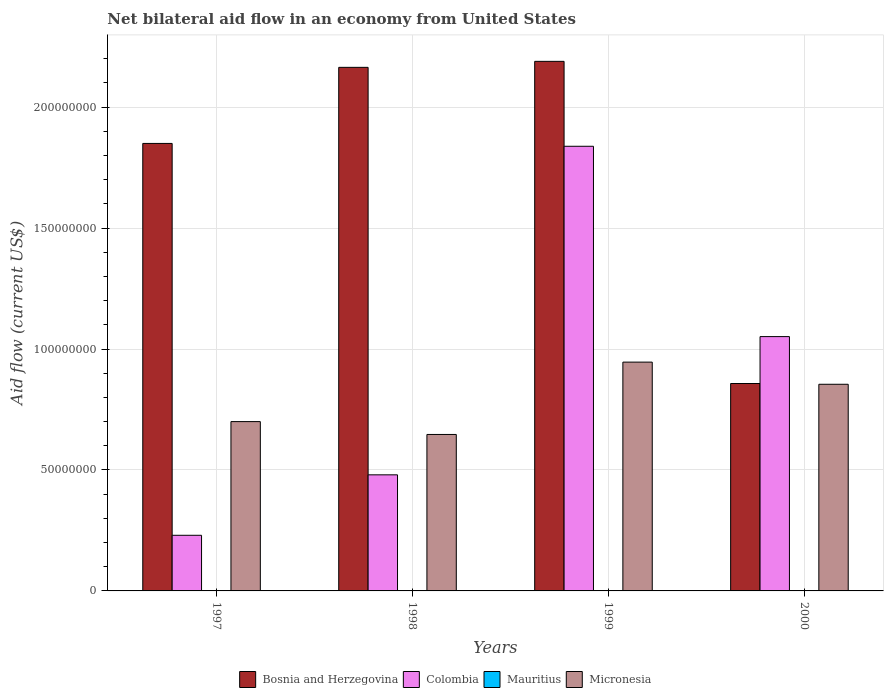Are the number of bars per tick equal to the number of legend labels?
Provide a succinct answer. No. How many bars are there on the 1st tick from the left?
Your response must be concise. 3. How many bars are there on the 4th tick from the right?
Ensure brevity in your answer.  3. What is the net bilateral aid flow in Colombia in 1997?
Ensure brevity in your answer.  2.30e+07. Across all years, what is the maximum net bilateral aid flow in Colombia?
Give a very brief answer. 1.84e+08. In which year was the net bilateral aid flow in Bosnia and Herzegovina maximum?
Provide a succinct answer. 1999. What is the total net bilateral aid flow in Colombia in the graph?
Make the answer very short. 3.60e+08. What is the difference between the net bilateral aid flow in Bosnia and Herzegovina in 1998 and that in 2000?
Offer a very short reply. 1.31e+08. What is the difference between the net bilateral aid flow in Bosnia and Herzegovina in 1997 and the net bilateral aid flow in Mauritius in 1999?
Give a very brief answer. 1.85e+08. What is the average net bilateral aid flow in Colombia per year?
Offer a very short reply. 9.00e+07. In the year 2000, what is the difference between the net bilateral aid flow in Colombia and net bilateral aid flow in Bosnia and Herzegovina?
Give a very brief answer. 1.94e+07. What is the ratio of the net bilateral aid flow in Micronesia in 1998 to that in 2000?
Give a very brief answer. 0.76. Is the difference between the net bilateral aid flow in Colombia in 1997 and 2000 greater than the difference between the net bilateral aid flow in Bosnia and Herzegovina in 1997 and 2000?
Offer a terse response. No. What is the difference between the highest and the second highest net bilateral aid flow in Micronesia?
Offer a terse response. 9.16e+06. What is the difference between the highest and the lowest net bilateral aid flow in Bosnia and Herzegovina?
Provide a short and direct response. 1.33e+08. In how many years, is the net bilateral aid flow in Mauritius greater than the average net bilateral aid flow in Mauritius taken over all years?
Provide a succinct answer. 0. Is the sum of the net bilateral aid flow in Colombia in 1998 and 2000 greater than the maximum net bilateral aid flow in Bosnia and Herzegovina across all years?
Offer a terse response. No. Is it the case that in every year, the sum of the net bilateral aid flow in Bosnia and Herzegovina and net bilateral aid flow in Mauritius is greater than the sum of net bilateral aid flow in Colombia and net bilateral aid flow in Micronesia?
Offer a very short reply. No. Is it the case that in every year, the sum of the net bilateral aid flow in Colombia and net bilateral aid flow in Micronesia is greater than the net bilateral aid flow in Mauritius?
Your answer should be compact. Yes. Are all the bars in the graph horizontal?
Offer a terse response. No. Does the graph contain any zero values?
Give a very brief answer. Yes. Does the graph contain grids?
Ensure brevity in your answer.  Yes. Where does the legend appear in the graph?
Give a very brief answer. Bottom center. How many legend labels are there?
Your answer should be compact. 4. How are the legend labels stacked?
Provide a short and direct response. Horizontal. What is the title of the graph?
Provide a succinct answer. Net bilateral aid flow in an economy from United States. What is the label or title of the X-axis?
Make the answer very short. Years. What is the label or title of the Y-axis?
Ensure brevity in your answer.  Aid flow (current US$). What is the Aid flow (current US$) of Bosnia and Herzegovina in 1997?
Offer a very short reply. 1.85e+08. What is the Aid flow (current US$) in Colombia in 1997?
Offer a very short reply. 2.30e+07. What is the Aid flow (current US$) in Micronesia in 1997?
Offer a terse response. 7.00e+07. What is the Aid flow (current US$) of Bosnia and Herzegovina in 1998?
Offer a terse response. 2.16e+08. What is the Aid flow (current US$) in Colombia in 1998?
Provide a short and direct response. 4.80e+07. What is the Aid flow (current US$) of Mauritius in 1998?
Provide a short and direct response. 0. What is the Aid flow (current US$) in Micronesia in 1998?
Offer a terse response. 6.47e+07. What is the Aid flow (current US$) of Bosnia and Herzegovina in 1999?
Provide a short and direct response. 2.19e+08. What is the Aid flow (current US$) of Colombia in 1999?
Your response must be concise. 1.84e+08. What is the Aid flow (current US$) in Micronesia in 1999?
Offer a terse response. 9.46e+07. What is the Aid flow (current US$) of Bosnia and Herzegovina in 2000?
Your response must be concise. 8.58e+07. What is the Aid flow (current US$) of Colombia in 2000?
Ensure brevity in your answer.  1.05e+08. What is the Aid flow (current US$) of Micronesia in 2000?
Provide a succinct answer. 8.54e+07. Across all years, what is the maximum Aid flow (current US$) of Bosnia and Herzegovina?
Offer a terse response. 2.19e+08. Across all years, what is the maximum Aid flow (current US$) in Colombia?
Offer a very short reply. 1.84e+08. Across all years, what is the maximum Aid flow (current US$) of Micronesia?
Your answer should be very brief. 9.46e+07. Across all years, what is the minimum Aid flow (current US$) of Bosnia and Herzegovina?
Make the answer very short. 8.58e+07. Across all years, what is the minimum Aid flow (current US$) in Colombia?
Make the answer very short. 2.30e+07. Across all years, what is the minimum Aid flow (current US$) in Micronesia?
Your response must be concise. 6.47e+07. What is the total Aid flow (current US$) of Bosnia and Herzegovina in the graph?
Offer a terse response. 7.06e+08. What is the total Aid flow (current US$) of Colombia in the graph?
Your answer should be compact. 3.60e+08. What is the total Aid flow (current US$) of Micronesia in the graph?
Provide a short and direct response. 3.15e+08. What is the difference between the Aid flow (current US$) of Bosnia and Herzegovina in 1997 and that in 1998?
Provide a short and direct response. -3.14e+07. What is the difference between the Aid flow (current US$) in Colombia in 1997 and that in 1998?
Provide a short and direct response. -2.50e+07. What is the difference between the Aid flow (current US$) in Micronesia in 1997 and that in 1998?
Offer a very short reply. 5.32e+06. What is the difference between the Aid flow (current US$) of Bosnia and Herzegovina in 1997 and that in 1999?
Provide a short and direct response. -3.39e+07. What is the difference between the Aid flow (current US$) in Colombia in 1997 and that in 1999?
Keep it short and to the point. -1.61e+08. What is the difference between the Aid flow (current US$) of Micronesia in 1997 and that in 1999?
Ensure brevity in your answer.  -2.46e+07. What is the difference between the Aid flow (current US$) in Bosnia and Herzegovina in 1997 and that in 2000?
Provide a short and direct response. 9.92e+07. What is the difference between the Aid flow (current US$) of Colombia in 1997 and that in 2000?
Give a very brief answer. -8.21e+07. What is the difference between the Aid flow (current US$) in Micronesia in 1997 and that in 2000?
Provide a short and direct response. -1.54e+07. What is the difference between the Aid flow (current US$) in Bosnia and Herzegovina in 1998 and that in 1999?
Provide a succinct answer. -2.48e+06. What is the difference between the Aid flow (current US$) of Colombia in 1998 and that in 1999?
Provide a succinct answer. -1.36e+08. What is the difference between the Aid flow (current US$) in Micronesia in 1998 and that in 1999?
Your answer should be very brief. -2.99e+07. What is the difference between the Aid flow (current US$) of Bosnia and Herzegovina in 1998 and that in 2000?
Offer a terse response. 1.31e+08. What is the difference between the Aid flow (current US$) of Colombia in 1998 and that in 2000?
Offer a terse response. -5.72e+07. What is the difference between the Aid flow (current US$) of Micronesia in 1998 and that in 2000?
Your response must be concise. -2.08e+07. What is the difference between the Aid flow (current US$) of Bosnia and Herzegovina in 1999 and that in 2000?
Keep it short and to the point. 1.33e+08. What is the difference between the Aid flow (current US$) in Colombia in 1999 and that in 2000?
Offer a terse response. 7.87e+07. What is the difference between the Aid flow (current US$) of Micronesia in 1999 and that in 2000?
Provide a succinct answer. 9.16e+06. What is the difference between the Aid flow (current US$) in Bosnia and Herzegovina in 1997 and the Aid flow (current US$) in Colombia in 1998?
Offer a very short reply. 1.37e+08. What is the difference between the Aid flow (current US$) of Bosnia and Herzegovina in 1997 and the Aid flow (current US$) of Micronesia in 1998?
Ensure brevity in your answer.  1.20e+08. What is the difference between the Aid flow (current US$) of Colombia in 1997 and the Aid flow (current US$) of Micronesia in 1998?
Offer a very short reply. -4.17e+07. What is the difference between the Aid flow (current US$) in Bosnia and Herzegovina in 1997 and the Aid flow (current US$) in Colombia in 1999?
Make the answer very short. 1.18e+06. What is the difference between the Aid flow (current US$) in Bosnia and Herzegovina in 1997 and the Aid flow (current US$) in Micronesia in 1999?
Your answer should be compact. 9.04e+07. What is the difference between the Aid flow (current US$) of Colombia in 1997 and the Aid flow (current US$) of Micronesia in 1999?
Make the answer very short. -7.16e+07. What is the difference between the Aid flow (current US$) in Bosnia and Herzegovina in 1997 and the Aid flow (current US$) in Colombia in 2000?
Offer a very short reply. 7.99e+07. What is the difference between the Aid flow (current US$) in Bosnia and Herzegovina in 1997 and the Aid flow (current US$) in Micronesia in 2000?
Your response must be concise. 9.96e+07. What is the difference between the Aid flow (current US$) of Colombia in 1997 and the Aid flow (current US$) of Micronesia in 2000?
Keep it short and to the point. -6.24e+07. What is the difference between the Aid flow (current US$) of Bosnia and Herzegovina in 1998 and the Aid flow (current US$) of Colombia in 1999?
Your answer should be compact. 3.26e+07. What is the difference between the Aid flow (current US$) in Bosnia and Herzegovina in 1998 and the Aid flow (current US$) in Micronesia in 1999?
Provide a succinct answer. 1.22e+08. What is the difference between the Aid flow (current US$) in Colombia in 1998 and the Aid flow (current US$) in Micronesia in 1999?
Offer a terse response. -4.66e+07. What is the difference between the Aid flow (current US$) of Bosnia and Herzegovina in 1998 and the Aid flow (current US$) of Colombia in 2000?
Keep it short and to the point. 1.11e+08. What is the difference between the Aid flow (current US$) of Bosnia and Herzegovina in 1998 and the Aid flow (current US$) of Micronesia in 2000?
Your answer should be very brief. 1.31e+08. What is the difference between the Aid flow (current US$) of Colombia in 1998 and the Aid flow (current US$) of Micronesia in 2000?
Make the answer very short. -3.74e+07. What is the difference between the Aid flow (current US$) in Bosnia and Herzegovina in 1999 and the Aid flow (current US$) in Colombia in 2000?
Your response must be concise. 1.14e+08. What is the difference between the Aid flow (current US$) of Bosnia and Herzegovina in 1999 and the Aid flow (current US$) of Micronesia in 2000?
Your answer should be compact. 1.34e+08. What is the difference between the Aid flow (current US$) of Colombia in 1999 and the Aid flow (current US$) of Micronesia in 2000?
Offer a terse response. 9.84e+07. What is the average Aid flow (current US$) in Bosnia and Herzegovina per year?
Provide a succinct answer. 1.77e+08. What is the average Aid flow (current US$) in Colombia per year?
Your response must be concise. 9.00e+07. What is the average Aid flow (current US$) in Mauritius per year?
Offer a very short reply. 0. What is the average Aid flow (current US$) of Micronesia per year?
Keep it short and to the point. 7.87e+07. In the year 1997, what is the difference between the Aid flow (current US$) of Bosnia and Herzegovina and Aid flow (current US$) of Colombia?
Offer a very short reply. 1.62e+08. In the year 1997, what is the difference between the Aid flow (current US$) in Bosnia and Herzegovina and Aid flow (current US$) in Micronesia?
Provide a short and direct response. 1.15e+08. In the year 1997, what is the difference between the Aid flow (current US$) in Colombia and Aid flow (current US$) in Micronesia?
Your answer should be compact. -4.70e+07. In the year 1998, what is the difference between the Aid flow (current US$) in Bosnia and Herzegovina and Aid flow (current US$) in Colombia?
Ensure brevity in your answer.  1.68e+08. In the year 1998, what is the difference between the Aid flow (current US$) of Bosnia and Herzegovina and Aid flow (current US$) of Micronesia?
Your response must be concise. 1.52e+08. In the year 1998, what is the difference between the Aid flow (current US$) in Colombia and Aid flow (current US$) in Micronesia?
Your answer should be very brief. -1.67e+07. In the year 1999, what is the difference between the Aid flow (current US$) of Bosnia and Herzegovina and Aid flow (current US$) of Colombia?
Keep it short and to the point. 3.51e+07. In the year 1999, what is the difference between the Aid flow (current US$) in Bosnia and Herzegovina and Aid flow (current US$) in Micronesia?
Your answer should be very brief. 1.24e+08. In the year 1999, what is the difference between the Aid flow (current US$) of Colombia and Aid flow (current US$) of Micronesia?
Keep it short and to the point. 8.92e+07. In the year 2000, what is the difference between the Aid flow (current US$) of Bosnia and Herzegovina and Aid flow (current US$) of Colombia?
Provide a succinct answer. -1.94e+07. In the year 2000, what is the difference between the Aid flow (current US$) of Bosnia and Herzegovina and Aid flow (current US$) of Micronesia?
Offer a very short reply. 3.20e+05. In the year 2000, what is the difference between the Aid flow (current US$) in Colombia and Aid flow (current US$) in Micronesia?
Your response must be concise. 1.97e+07. What is the ratio of the Aid flow (current US$) in Bosnia and Herzegovina in 1997 to that in 1998?
Provide a short and direct response. 0.85. What is the ratio of the Aid flow (current US$) in Colombia in 1997 to that in 1998?
Your answer should be compact. 0.48. What is the ratio of the Aid flow (current US$) of Micronesia in 1997 to that in 1998?
Keep it short and to the point. 1.08. What is the ratio of the Aid flow (current US$) of Bosnia and Herzegovina in 1997 to that in 1999?
Offer a very short reply. 0.84. What is the ratio of the Aid flow (current US$) of Colombia in 1997 to that in 1999?
Your answer should be compact. 0.13. What is the ratio of the Aid flow (current US$) of Micronesia in 1997 to that in 1999?
Give a very brief answer. 0.74. What is the ratio of the Aid flow (current US$) of Bosnia and Herzegovina in 1997 to that in 2000?
Provide a short and direct response. 2.16. What is the ratio of the Aid flow (current US$) in Colombia in 1997 to that in 2000?
Provide a succinct answer. 0.22. What is the ratio of the Aid flow (current US$) of Micronesia in 1997 to that in 2000?
Make the answer very short. 0.82. What is the ratio of the Aid flow (current US$) of Bosnia and Herzegovina in 1998 to that in 1999?
Offer a very short reply. 0.99. What is the ratio of the Aid flow (current US$) in Colombia in 1998 to that in 1999?
Your answer should be very brief. 0.26. What is the ratio of the Aid flow (current US$) of Micronesia in 1998 to that in 1999?
Provide a short and direct response. 0.68. What is the ratio of the Aid flow (current US$) of Bosnia and Herzegovina in 1998 to that in 2000?
Ensure brevity in your answer.  2.52. What is the ratio of the Aid flow (current US$) of Colombia in 1998 to that in 2000?
Your response must be concise. 0.46. What is the ratio of the Aid flow (current US$) in Micronesia in 1998 to that in 2000?
Your answer should be compact. 0.76. What is the ratio of the Aid flow (current US$) of Bosnia and Herzegovina in 1999 to that in 2000?
Offer a very short reply. 2.55. What is the ratio of the Aid flow (current US$) in Colombia in 1999 to that in 2000?
Offer a terse response. 1.75. What is the ratio of the Aid flow (current US$) in Micronesia in 1999 to that in 2000?
Provide a succinct answer. 1.11. What is the difference between the highest and the second highest Aid flow (current US$) in Bosnia and Herzegovina?
Make the answer very short. 2.48e+06. What is the difference between the highest and the second highest Aid flow (current US$) in Colombia?
Give a very brief answer. 7.87e+07. What is the difference between the highest and the second highest Aid flow (current US$) of Micronesia?
Offer a very short reply. 9.16e+06. What is the difference between the highest and the lowest Aid flow (current US$) of Bosnia and Herzegovina?
Offer a terse response. 1.33e+08. What is the difference between the highest and the lowest Aid flow (current US$) in Colombia?
Offer a terse response. 1.61e+08. What is the difference between the highest and the lowest Aid flow (current US$) in Micronesia?
Make the answer very short. 2.99e+07. 